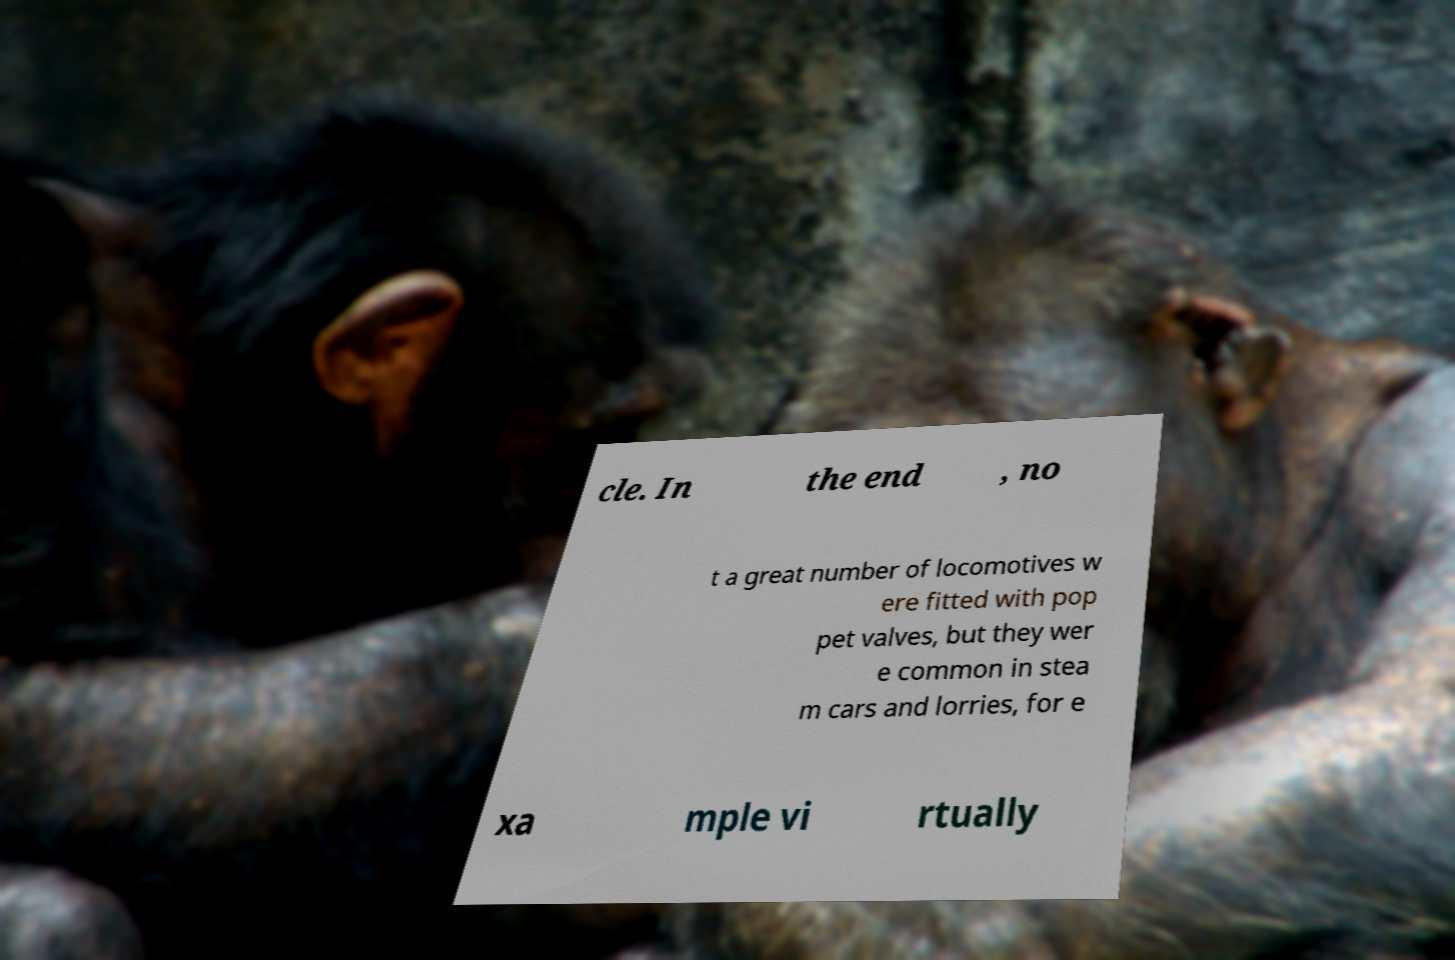For documentation purposes, I need the text within this image transcribed. Could you provide that? cle. In the end , no t a great number of locomotives w ere fitted with pop pet valves, but they wer e common in stea m cars and lorries, for e xa mple vi rtually 